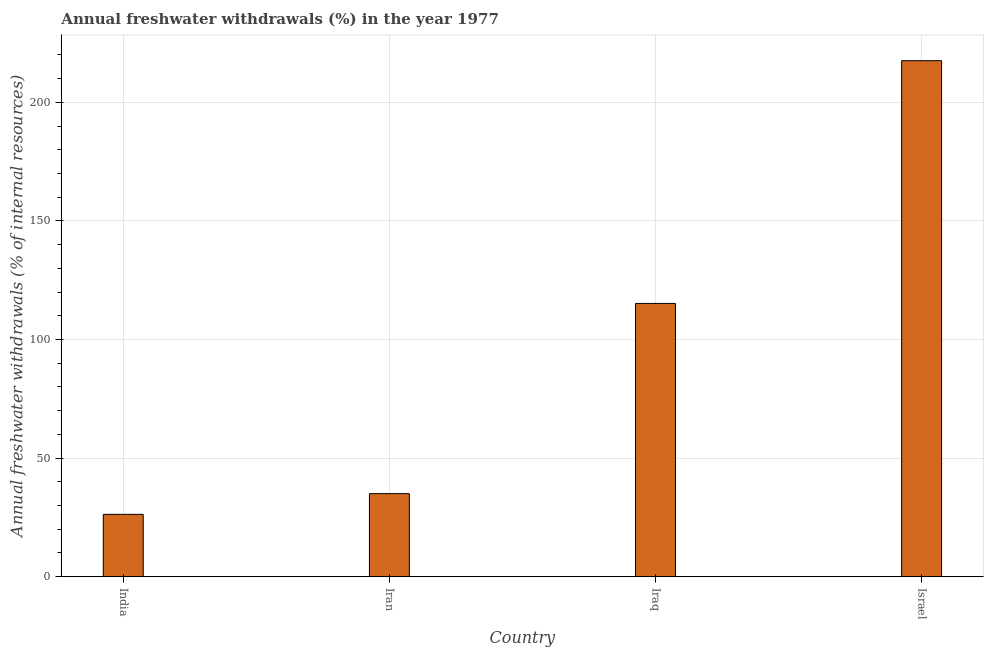Does the graph contain grids?
Offer a terse response. Yes. What is the title of the graph?
Offer a terse response. Annual freshwater withdrawals (%) in the year 1977. What is the label or title of the Y-axis?
Your response must be concise. Annual freshwater withdrawals (% of internal resources). What is the annual freshwater withdrawals in Iran?
Offer a terse response. 35.02. Across all countries, what is the maximum annual freshwater withdrawals?
Your answer should be compact. 217.6. Across all countries, what is the minimum annual freshwater withdrawals?
Your response must be concise. 26.28. In which country was the annual freshwater withdrawals maximum?
Keep it short and to the point. Israel. What is the sum of the annual freshwater withdrawals?
Provide a succinct answer. 394.13. What is the difference between the annual freshwater withdrawals in India and Iraq?
Provide a short and direct response. -88.95. What is the average annual freshwater withdrawals per country?
Give a very brief answer. 98.53. What is the median annual freshwater withdrawals?
Offer a very short reply. 75.12. In how many countries, is the annual freshwater withdrawals greater than 70 %?
Keep it short and to the point. 2. What is the ratio of the annual freshwater withdrawals in Iran to that in Israel?
Offer a very short reply. 0.16. Is the annual freshwater withdrawals in Iraq less than that in Israel?
Your answer should be compact. Yes. What is the difference between the highest and the second highest annual freshwater withdrawals?
Provide a short and direct response. 102.37. Is the sum of the annual freshwater withdrawals in India and Iraq greater than the maximum annual freshwater withdrawals across all countries?
Offer a terse response. No. What is the difference between the highest and the lowest annual freshwater withdrawals?
Your response must be concise. 191.32. How many countries are there in the graph?
Your answer should be compact. 4. Are the values on the major ticks of Y-axis written in scientific E-notation?
Offer a terse response. No. What is the Annual freshwater withdrawals (% of internal resources) of India?
Your response must be concise. 26.28. What is the Annual freshwater withdrawals (% of internal resources) in Iran?
Offer a very short reply. 35.02. What is the Annual freshwater withdrawals (% of internal resources) of Iraq?
Make the answer very short. 115.23. What is the Annual freshwater withdrawals (% of internal resources) of Israel?
Give a very brief answer. 217.6. What is the difference between the Annual freshwater withdrawals (% of internal resources) in India and Iran?
Give a very brief answer. -8.74. What is the difference between the Annual freshwater withdrawals (% of internal resources) in India and Iraq?
Your answer should be compact. -88.95. What is the difference between the Annual freshwater withdrawals (% of internal resources) in India and Israel?
Provide a short and direct response. -191.32. What is the difference between the Annual freshwater withdrawals (% of internal resources) in Iran and Iraq?
Make the answer very short. -80.21. What is the difference between the Annual freshwater withdrawals (% of internal resources) in Iran and Israel?
Your response must be concise. -182.58. What is the difference between the Annual freshwater withdrawals (% of internal resources) in Iraq and Israel?
Provide a short and direct response. -102.37. What is the ratio of the Annual freshwater withdrawals (% of internal resources) in India to that in Iran?
Your response must be concise. 0.75. What is the ratio of the Annual freshwater withdrawals (% of internal resources) in India to that in Iraq?
Offer a very short reply. 0.23. What is the ratio of the Annual freshwater withdrawals (% of internal resources) in India to that in Israel?
Keep it short and to the point. 0.12. What is the ratio of the Annual freshwater withdrawals (% of internal resources) in Iran to that in Iraq?
Give a very brief answer. 0.3. What is the ratio of the Annual freshwater withdrawals (% of internal resources) in Iran to that in Israel?
Offer a very short reply. 0.16. What is the ratio of the Annual freshwater withdrawals (% of internal resources) in Iraq to that in Israel?
Keep it short and to the point. 0.53. 